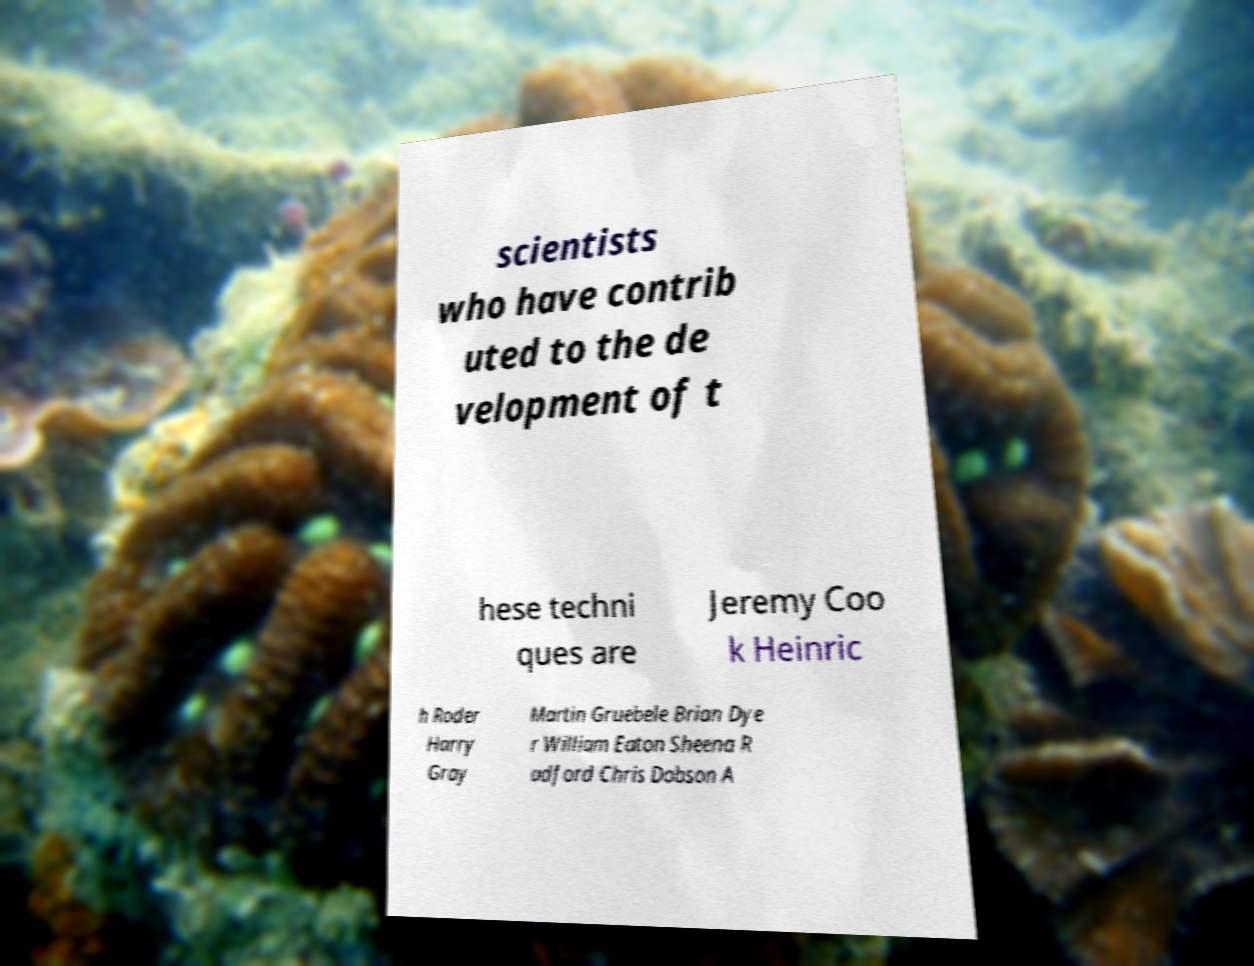Can you read and provide the text displayed in the image?This photo seems to have some interesting text. Can you extract and type it out for me? scientists who have contrib uted to the de velopment of t hese techni ques are Jeremy Coo k Heinric h Roder Harry Gray Martin Gruebele Brian Dye r William Eaton Sheena R adford Chris Dobson A 